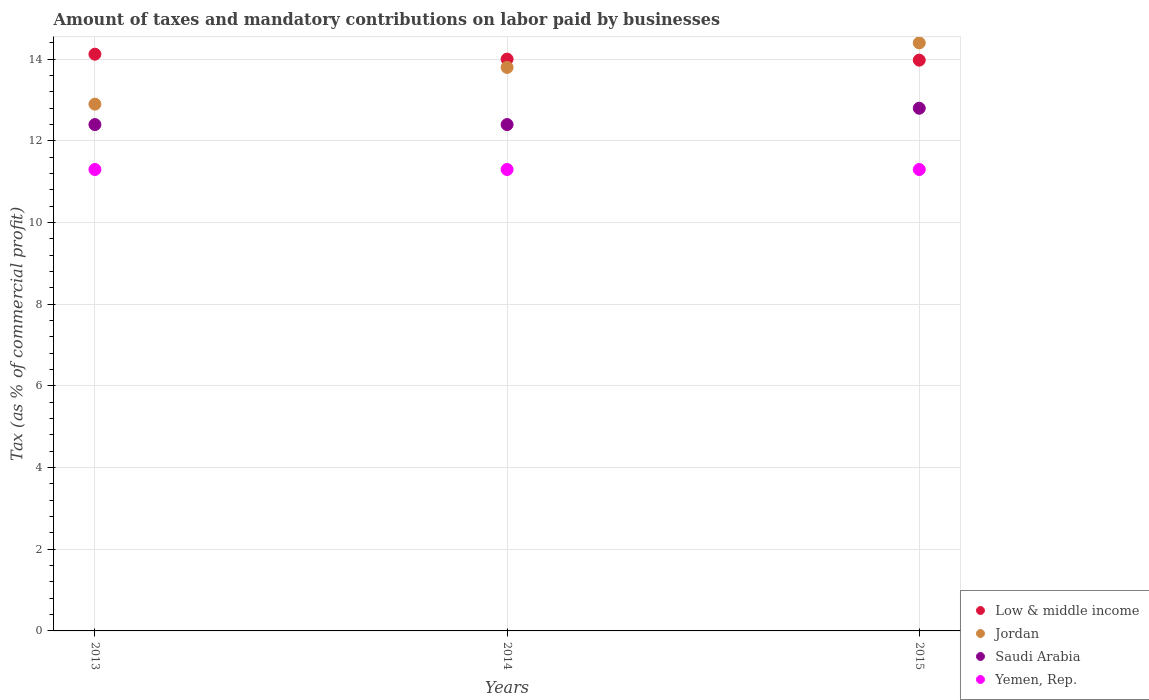Is the number of dotlines equal to the number of legend labels?
Your response must be concise. Yes. What is the percentage of taxes paid by businesses in Saudi Arabia in 2013?
Provide a short and direct response. 12.4. In which year was the percentage of taxes paid by businesses in Jordan maximum?
Make the answer very short. 2015. What is the total percentage of taxes paid by businesses in Low & middle income in the graph?
Provide a short and direct response. 42.1. What is the difference between the percentage of taxes paid by businesses in Low & middle income in 2014 and that in 2015?
Provide a short and direct response. 0.03. What is the average percentage of taxes paid by businesses in Yemen, Rep. per year?
Give a very brief answer. 11.3. In the year 2013, what is the difference between the percentage of taxes paid by businesses in Low & middle income and percentage of taxes paid by businesses in Jordan?
Your response must be concise. 1.22. In how many years, is the percentage of taxes paid by businesses in Jordan greater than 14 %?
Your answer should be very brief. 1. What is the ratio of the percentage of taxes paid by businesses in Low & middle income in 2014 to that in 2015?
Your answer should be compact. 1. Is the difference between the percentage of taxes paid by businesses in Low & middle income in 2013 and 2015 greater than the difference between the percentage of taxes paid by businesses in Jordan in 2013 and 2015?
Make the answer very short. Yes. What is the difference between the highest and the second highest percentage of taxes paid by businesses in Yemen, Rep.?
Your answer should be compact. 0. What is the difference between the highest and the lowest percentage of taxes paid by businesses in Saudi Arabia?
Offer a terse response. 0.4. In how many years, is the percentage of taxes paid by businesses in Jordan greater than the average percentage of taxes paid by businesses in Jordan taken over all years?
Your answer should be compact. 2. Is it the case that in every year, the sum of the percentage of taxes paid by businesses in Yemen, Rep. and percentage of taxes paid by businesses in Low & middle income  is greater than the percentage of taxes paid by businesses in Jordan?
Provide a short and direct response. Yes. Is the percentage of taxes paid by businesses in Yemen, Rep. strictly greater than the percentage of taxes paid by businesses in Jordan over the years?
Offer a very short reply. No. Is the percentage of taxes paid by businesses in Saudi Arabia strictly less than the percentage of taxes paid by businesses in Jordan over the years?
Your answer should be very brief. Yes. Are the values on the major ticks of Y-axis written in scientific E-notation?
Your answer should be very brief. No. Does the graph contain any zero values?
Offer a very short reply. No. Does the graph contain grids?
Offer a terse response. Yes. Where does the legend appear in the graph?
Give a very brief answer. Bottom right. How many legend labels are there?
Your answer should be compact. 4. How are the legend labels stacked?
Your answer should be very brief. Vertical. What is the title of the graph?
Your answer should be very brief. Amount of taxes and mandatory contributions on labor paid by businesses. What is the label or title of the Y-axis?
Make the answer very short. Tax (as % of commercial profit). What is the Tax (as % of commercial profit) of Low & middle income in 2013?
Offer a very short reply. 14.12. What is the Tax (as % of commercial profit) in Jordan in 2013?
Your answer should be very brief. 12.9. What is the Tax (as % of commercial profit) of Yemen, Rep. in 2013?
Keep it short and to the point. 11.3. What is the Tax (as % of commercial profit) of Low & middle income in 2014?
Your answer should be compact. 14. What is the Tax (as % of commercial profit) of Jordan in 2014?
Your answer should be very brief. 13.8. What is the Tax (as % of commercial profit) in Low & middle income in 2015?
Keep it short and to the point. 13.98. What is the Tax (as % of commercial profit) of Jordan in 2015?
Give a very brief answer. 14.4. What is the Tax (as % of commercial profit) of Yemen, Rep. in 2015?
Make the answer very short. 11.3. Across all years, what is the maximum Tax (as % of commercial profit) in Low & middle income?
Offer a terse response. 14.12. Across all years, what is the maximum Tax (as % of commercial profit) in Yemen, Rep.?
Provide a short and direct response. 11.3. Across all years, what is the minimum Tax (as % of commercial profit) in Low & middle income?
Provide a succinct answer. 13.98. Across all years, what is the minimum Tax (as % of commercial profit) of Jordan?
Provide a short and direct response. 12.9. What is the total Tax (as % of commercial profit) in Low & middle income in the graph?
Provide a succinct answer. 42.1. What is the total Tax (as % of commercial profit) in Jordan in the graph?
Make the answer very short. 41.1. What is the total Tax (as % of commercial profit) in Saudi Arabia in the graph?
Keep it short and to the point. 37.6. What is the total Tax (as % of commercial profit) in Yemen, Rep. in the graph?
Your answer should be compact. 33.9. What is the difference between the Tax (as % of commercial profit) in Low & middle income in 2013 and that in 2014?
Make the answer very short. 0.12. What is the difference between the Tax (as % of commercial profit) of Jordan in 2013 and that in 2014?
Keep it short and to the point. -0.9. What is the difference between the Tax (as % of commercial profit) in Saudi Arabia in 2013 and that in 2014?
Offer a terse response. 0. What is the difference between the Tax (as % of commercial profit) in Yemen, Rep. in 2013 and that in 2014?
Make the answer very short. 0. What is the difference between the Tax (as % of commercial profit) in Low & middle income in 2013 and that in 2015?
Provide a short and direct response. 0.15. What is the difference between the Tax (as % of commercial profit) in Low & middle income in 2014 and that in 2015?
Give a very brief answer. 0.03. What is the difference between the Tax (as % of commercial profit) in Low & middle income in 2013 and the Tax (as % of commercial profit) in Jordan in 2014?
Provide a succinct answer. 0.32. What is the difference between the Tax (as % of commercial profit) of Low & middle income in 2013 and the Tax (as % of commercial profit) of Saudi Arabia in 2014?
Offer a terse response. 1.72. What is the difference between the Tax (as % of commercial profit) in Low & middle income in 2013 and the Tax (as % of commercial profit) in Yemen, Rep. in 2014?
Give a very brief answer. 2.82. What is the difference between the Tax (as % of commercial profit) of Saudi Arabia in 2013 and the Tax (as % of commercial profit) of Yemen, Rep. in 2014?
Provide a succinct answer. 1.1. What is the difference between the Tax (as % of commercial profit) in Low & middle income in 2013 and the Tax (as % of commercial profit) in Jordan in 2015?
Make the answer very short. -0.28. What is the difference between the Tax (as % of commercial profit) in Low & middle income in 2013 and the Tax (as % of commercial profit) in Saudi Arabia in 2015?
Provide a short and direct response. 1.32. What is the difference between the Tax (as % of commercial profit) of Low & middle income in 2013 and the Tax (as % of commercial profit) of Yemen, Rep. in 2015?
Give a very brief answer. 2.82. What is the difference between the Tax (as % of commercial profit) of Jordan in 2013 and the Tax (as % of commercial profit) of Saudi Arabia in 2015?
Your response must be concise. 0.1. What is the difference between the Tax (as % of commercial profit) of Low & middle income in 2014 and the Tax (as % of commercial profit) of Jordan in 2015?
Provide a short and direct response. -0.4. What is the difference between the Tax (as % of commercial profit) in Low & middle income in 2014 and the Tax (as % of commercial profit) in Saudi Arabia in 2015?
Your response must be concise. 1.2. What is the difference between the Tax (as % of commercial profit) in Low & middle income in 2014 and the Tax (as % of commercial profit) in Yemen, Rep. in 2015?
Ensure brevity in your answer.  2.7. What is the difference between the Tax (as % of commercial profit) of Jordan in 2014 and the Tax (as % of commercial profit) of Saudi Arabia in 2015?
Give a very brief answer. 1. What is the difference between the Tax (as % of commercial profit) of Jordan in 2014 and the Tax (as % of commercial profit) of Yemen, Rep. in 2015?
Provide a succinct answer. 2.5. What is the average Tax (as % of commercial profit) in Low & middle income per year?
Make the answer very short. 14.03. What is the average Tax (as % of commercial profit) of Jordan per year?
Offer a very short reply. 13.7. What is the average Tax (as % of commercial profit) in Saudi Arabia per year?
Provide a succinct answer. 12.53. What is the average Tax (as % of commercial profit) of Yemen, Rep. per year?
Your answer should be compact. 11.3. In the year 2013, what is the difference between the Tax (as % of commercial profit) in Low & middle income and Tax (as % of commercial profit) in Jordan?
Your answer should be compact. 1.22. In the year 2013, what is the difference between the Tax (as % of commercial profit) of Low & middle income and Tax (as % of commercial profit) of Saudi Arabia?
Offer a terse response. 1.72. In the year 2013, what is the difference between the Tax (as % of commercial profit) in Low & middle income and Tax (as % of commercial profit) in Yemen, Rep.?
Offer a very short reply. 2.82. In the year 2013, what is the difference between the Tax (as % of commercial profit) in Jordan and Tax (as % of commercial profit) in Yemen, Rep.?
Ensure brevity in your answer.  1.6. In the year 2013, what is the difference between the Tax (as % of commercial profit) of Saudi Arabia and Tax (as % of commercial profit) of Yemen, Rep.?
Your answer should be compact. 1.1. In the year 2014, what is the difference between the Tax (as % of commercial profit) in Low & middle income and Tax (as % of commercial profit) in Jordan?
Give a very brief answer. 0.2. In the year 2014, what is the difference between the Tax (as % of commercial profit) of Low & middle income and Tax (as % of commercial profit) of Saudi Arabia?
Make the answer very short. 1.6. In the year 2014, what is the difference between the Tax (as % of commercial profit) in Low & middle income and Tax (as % of commercial profit) in Yemen, Rep.?
Offer a terse response. 2.7. In the year 2014, what is the difference between the Tax (as % of commercial profit) in Jordan and Tax (as % of commercial profit) in Saudi Arabia?
Offer a very short reply. 1.4. In the year 2014, what is the difference between the Tax (as % of commercial profit) of Saudi Arabia and Tax (as % of commercial profit) of Yemen, Rep.?
Offer a very short reply. 1.1. In the year 2015, what is the difference between the Tax (as % of commercial profit) of Low & middle income and Tax (as % of commercial profit) of Jordan?
Keep it short and to the point. -0.42. In the year 2015, what is the difference between the Tax (as % of commercial profit) of Low & middle income and Tax (as % of commercial profit) of Saudi Arabia?
Your answer should be very brief. 1.18. In the year 2015, what is the difference between the Tax (as % of commercial profit) in Low & middle income and Tax (as % of commercial profit) in Yemen, Rep.?
Provide a succinct answer. 2.68. In the year 2015, what is the difference between the Tax (as % of commercial profit) in Jordan and Tax (as % of commercial profit) in Yemen, Rep.?
Your response must be concise. 3.1. In the year 2015, what is the difference between the Tax (as % of commercial profit) of Saudi Arabia and Tax (as % of commercial profit) of Yemen, Rep.?
Provide a succinct answer. 1.5. What is the ratio of the Tax (as % of commercial profit) in Low & middle income in 2013 to that in 2014?
Make the answer very short. 1.01. What is the ratio of the Tax (as % of commercial profit) of Jordan in 2013 to that in 2014?
Provide a short and direct response. 0.93. What is the ratio of the Tax (as % of commercial profit) of Low & middle income in 2013 to that in 2015?
Provide a short and direct response. 1.01. What is the ratio of the Tax (as % of commercial profit) in Jordan in 2013 to that in 2015?
Your response must be concise. 0.9. What is the ratio of the Tax (as % of commercial profit) of Saudi Arabia in 2013 to that in 2015?
Make the answer very short. 0.97. What is the ratio of the Tax (as % of commercial profit) in Yemen, Rep. in 2013 to that in 2015?
Your answer should be compact. 1. What is the ratio of the Tax (as % of commercial profit) in Low & middle income in 2014 to that in 2015?
Keep it short and to the point. 1. What is the ratio of the Tax (as % of commercial profit) of Jordan in 2014 to that in 2015?
Your answer should be very brief. 0.96. What is the ratio of the Tax (as % of commercial profit) in Saudi Arabia in 2014 to that in 2015?
Keep it short and to the point. 0.97. What is the difference between the highest and the second highest Tax (as % of commercial profit) of Low & middle income?
Offer a very short reply. 0.12. What is the difference between the highest and the second highest Tax (as % of commercial profit) of Jordan?
Your answer should be compact. 0.6. What is the difference between the highest and the second highest Tax (as % of commercial profit) in Yemen, Rep.?
Provide a short and direct response. 0. What is the difference between the highest and the lowest Tax (as % of commercial profit) of Low & middle income?
Ensure brevity in your answer.  0.15. What is the difference between the highest and the lowest Tax (as % of commercial profit) of Jordan?
Keep it short and to the point. 1.5. What is the difference between the highest and the lowest Tax (as % of commercial profit) in Saudi Arabia?
Offer a terse response. 0.4. What is the difference between the highest and the lowest Tax (as % of commercial profit) of Yemen, Rep.?
Your response must be concise. 0. 